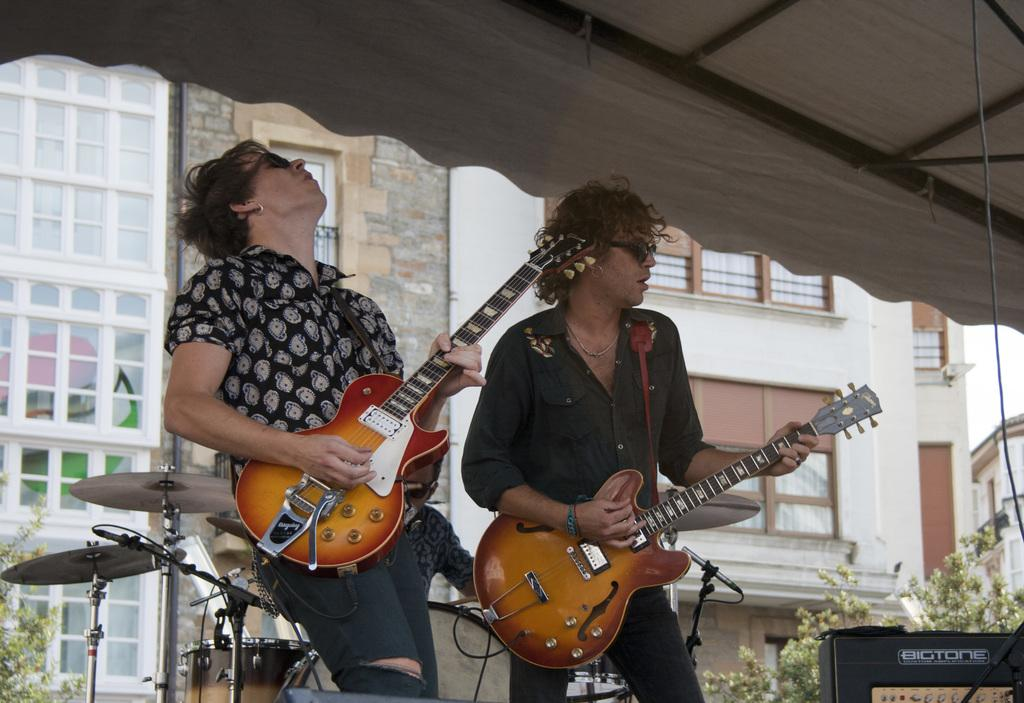How many people are in the image? There are two persons in the image. What are the persons doing in the image? The persons are standing and singing. What instruments are the persons holding? The persons are holding guitars. What can be seen on the left side of the side of the image? There is a tree on the left side of the image. What other musical instrument is present in the image? There are drums in the image. What is visible in the background of the image? There is a building in the background of the image. What type of knee injury is the woman on the right side of the image suffering from? There are no women present in the image, and no one is shown to be suffering from a knee injury. Is there a prison visible in the image? No, there is no prison present in the image. 